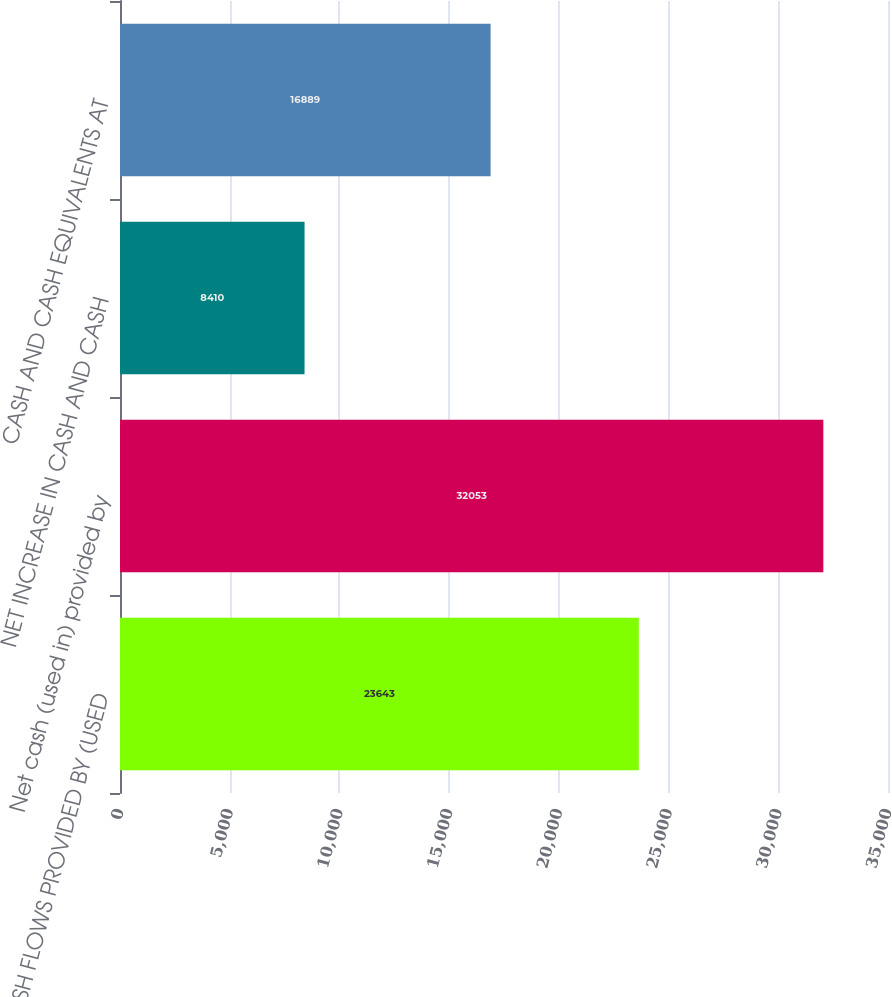<chart> <loc_0><loc_0><loc_500><loc_500><bar_chart><fcel>CASH FLOWS PROVIDED BY (USED<fcel>Net cash (used in) provided by<fcel>NET INCREASE IN CASH AND CASH<fcel>CASH AND CASH EQUIVALENTS AT<nl><fcel>23643<fcel>32053<fcel>8410<fcel>16889<nl></chart> 